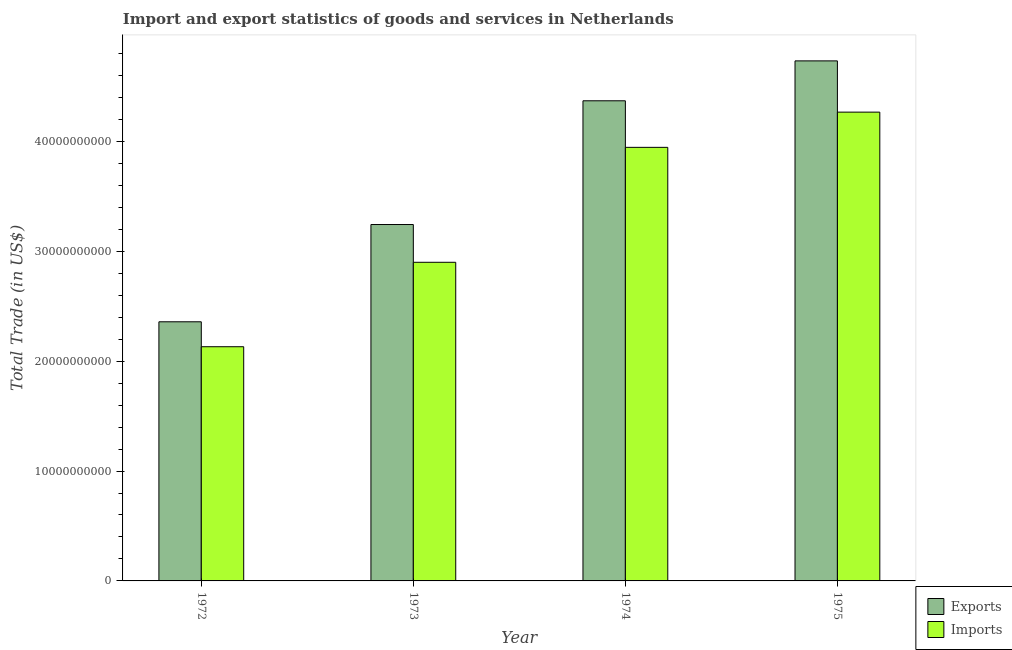Are the number of bars on each tick of the X-axis equal?
Offer a terse response. Yes. How many bars are there on the 4th tick from the left?
Your response must be concise. 2. How many bars are there on the 3rd tick from the right?
Offer a terse response. 2. What is the label of the 3rd group of bars from the left?
Offer a very short reply. 1974. What is the imports of goods and services in 1972?
Your answer should be compact. 2.13e+1. Across all years, what is the maximum imports of goods and services?
Offer a terse response. 4.27e+1. Across all years, what is the minimum imports of goods and services?
Offer a very short reply. 2.13e+1. In which year was the export of goods and services maximum?
Offer a terse response. 1975. In which year was the export of goods and services minimum?
Offer a terse response. 1972. What is the total imports of goods and services in the graph?
Your answer should be compact. 1.32e+11. What is the difference between the imports of goods and services in 1974 and that in 1975?
Your answer should be very brief. -3.20e+09. What is the difference between the export of goods and services in 1974 and the imports of goods and services in 1972?
Offer a terse response. 2.01e+1. What is the average imports of goods and services per year?
Your response must be concise. 3.31e+1. What is the ratio of the export of goods and services in 1973 to that in 1975?
Make the answer very short. 0.69. Is the imports of goods and services in 1974 less than that in 1975?
Your answer should be very brief. Yes. What is the difference between the highest and the second highest imports of goods and services?
Give a very brief answer. 3.20e+09. What is the difference between the highest and the lowest export of goods and services?
Provide a short and direct response. 2.37e+1. In how many years, is the imports of goods and services greater than the average imports of goods and services taken over all years?
Your response must be concise. 2. What does the 2nd bar from the left in 1975 represents?
Make the answer very short. Imports. What does the 1st bar from the right in 1972 represents?
Offer a terse response. Imports. How many years are there in the graph?
Make the answer very short. 4. How many legend labels are there?
Your response must be concise. 2. What is the title of the graph?
Give a very brief answer. Import and export statistics of goods and services in Netherlands. What is the label or title of the X-axis?
Your answer should be compact. Year. What is the label or title of the Y-axis?
Ensure brevity in your answer.  Total Trade (in US$). What is the Total Trade (in US$) in Exports in 1972?
Offer a very short reply. 2.36e+1. What is the Total Trade (in US$) of Imports in 1972?
Your answer should be compact. 2.13e+1. What is the Total Trade (in US$) of Exports in 1973?
Offer a terse response. 3.24e+1. What is the Total Trade (in US$) of Imports in 1973?
Your response must be concise. 2.90e+1. What is the Total Trade (in US$) in Exports in 1974?
Your answer should be very brief. 4.37e+1. What is the Total Trade (in US$) of Imports in 1974?
Make the answer very short. 3.95e+1. What is the Total Trade (in US$) in Exports in 1975?
Offer a very short reply. 4.73e+1. What is the Total Trade (in US$) in Imports in 1975?
Keep it short and to the point. 4.27e+1. Across all years, what is the maximum Total Trade (in US$) in Exports?
Your response must be concise. 4.73e+1. Across all years, what is the maximum Total Trade (in US$) in Imports?
Your answer should be compact. 4.27e+1. Across all years, what is the minimum Total Trade (in US$) in Exports?
Your answer should be compact. 2.36e+1. Across all years, what is the minimum Total Trade (in US$) in Imports?
Offer a terse response. 2.13e+1. What is the total Total Trade (in US$) of Exports in the graph?
Your response must be concise. 1.47e+11. What is the total Total Trade (in US$) in Imports in the graph?
Provide a succinct answer. 1.32e+11. What is the difference between the Total Trade (in US$) in Exports in 1972 and that in 1973?
Give a very brief answer. -8.85e+09. What is the difference between the Total Trade (in US$) in Imports in 1972 and that in 1973?
Offer a terse response. -7.68e+09. What is the difference between the Total Trade (in US$) of Exports in 1972 and that in 1974?
Offer a terse response. -2.01e+1. What is the difference between the Total Trade (in US$) in Imports in 1972 and that in 1974?
Your answer should be very brief. -1.81e+1. What is the difference between the Total Trade (in US$) of Exports in 1972 and that in 1975?
Make the answer very short. -2.37e+1. What is the difference between the Total Trade (in US$) in Imports in 1972 and that in 1975?
Offer a very short reply. -2.13e+1. What is the difference between the Total Trade (in US$) in Exports in 1973 and that in 1974?
Make the answer very short. -1.13e+1. What is the difference between the Total Trade (in US$) in Imports in 1973 and that in 1974?
Give a very brief answer. -1.05e+1. What is the difference between the Total Trade (in US$) in Exports in 1973 and that in 1975?
Your answer should be very brief. -1.49e+1. What is the difference between the Total Trade (in US$) in Imports in 1973 and that in 1975?
Offer a very short reply. -1.37e+1. What is the difference between the Total Trade (in US$) of Exports in 1974 and that in 1975?
Your response must be concise. -3.63e+09. What is the difference between the Total Trade (in US$) in Imports in 1974 and that in 1975?
Provide a succinct answer. -3.20e+09. What is the difference between the Total Trade (in US$) of Exports in 1972 and the Total Trade (in US$) of Imports in 1973?
Keep it short and to the point. -5.41e+09. What is the difference between the Total Trade (in US$) of Exports in 1972 and the Total Trade (in US$) of Imports in 1974?
Keep it short and to the point. -1.59e+1. What is the difference between the Total Trade (in US$) in Exports in 1972 and the Total Trade (in US$) in Imports in 1975?
Your response must be concise. -1.91e+1. What is the difference between the Total Trade (in US$) in Exports in 1973 and the Total Trade (in US$) in Imports in 1974?
Offer a very short reply. -7.02e+09. What is the difference between the Total Trade (in US$) in Exports in 1973 and the Total Trade (in US$) in Imports in 1975?
Make the answer very short. -1.02e+1. What is the difference between the Total Trade (in US$) in Exports in 1974 and the Total Trade (in US$) in Imports in 1975?
Give a very brief answer. 1.03e+09. What is the average Total Trade (in US$) in Exports per year?
Give a very brief answer. 3.68e+1. What is the average Total Trade (in US$) in Imports per year?
Your response must be concise. 3.31e+1. In the year 1972, what is the difference between the Total Trade (in US$) of Exports and Total Trade (in US$) of Imports?
Your answer should be compact. 2.27e+09. In the year 1973, what is the difference between the Total Trade (in US$) of Exports and Total Trade (in US$) of Imports?
Provide a short and direct response. 3.44e+09. In the year 1974, what is the difference between the Total Trade (in US$) of Exports and Total Trade (in US$) of Imports?
Offer a very short reply. 4.24e+09. In the year 1975, what is the difference between the Total Trade (in US$) of Exports and Total Trade (in US$) of Imports?
Your answer should be compact. 4.66e+09. What is the ratio of the Total Trade (in US$) in Exports in 1972 to that in 1973?
Your response must be concise. 0.73. What is the ratio of the Total Trade (in US$) of Imports in 1972 to that in 1973?
Keep it short and to the point. 0.73. What is the ratio of the Total Trade (in US$) of Exports in 1972 to that in 1974?
Offer a very short reply. 0.54. What is the ratio of the Total Trade (in US$) in Imports in 1972 to that in 1974?
Your answer should be very brief. 0.54. What is the ratio of the Total Trade (in US$) in Exports in 1972 to that in 1975?
Offer a very short reply. 0.5. What is the ratio of the Total Trade (in US$) of Imports in 1972 to that in 1975?
Give a very brief answer. 0.5. What is the ratio of the Total Trade (in US$) in Exports in 1973 to that in 1974?
Provide a short and direct response. 0.74. What is the ratio of the Total Trade (in US$) of Imports in 1973 to that in 1974?
Your response must be concise. 0.73. What is the ratio of the Total Trade (in US$) of Exports in 1973 to that in 1975?
Your answer should be compact. 0.69. What is the ratio of the Total Trade (in US$) in Imports in 1973 to that in 1975?
Give a very brief answer. 0.68. What is the ratio of the Total Trade (in US$) of Exports in 1974 to that in 1975?
Make the answer very short. 0.92. What is the ratio of the Total Trade (in US$) in Imports in 1974 to that in 1975?
Make the answer very short. 0.92. What is the difference between the highest and the second highest Total Trade (in US$) of Exports?
Offer a very short reply. 3.63e+09. What is the difference between the highest and the second highest Total Trade (in US$) of Imports?
Your answer should be very brief. 3.20e+09. What is the difference between the highest and the lowest Total Trade (in US$) in Exports?
Provide a short and direct response. 2.37e+1. What is the difference between the highest and the lowest Total Trade (in US$) in Imports?
Provide a short and direct response. 2.13e+1. 